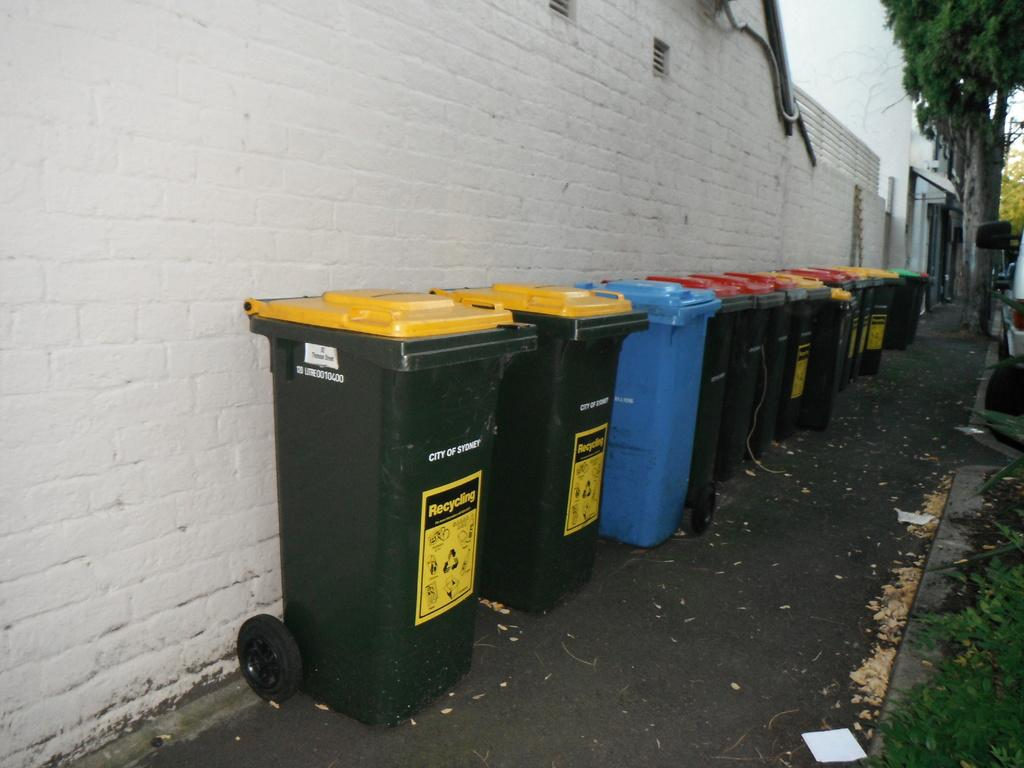<image>
Create a compact narrative representing the image presented. some trash barrels and some that say recycling 